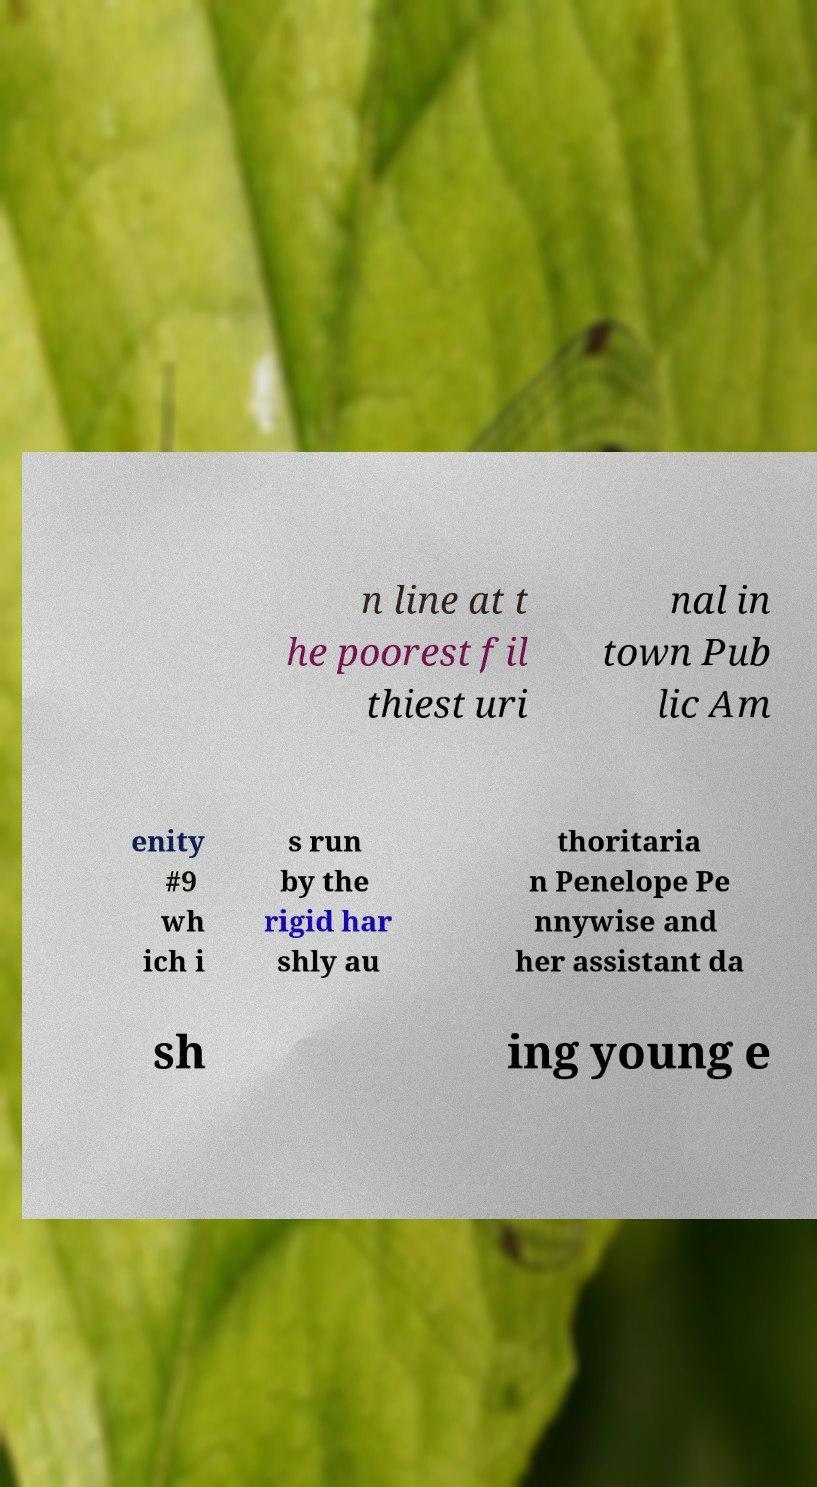Please identify and transcribe the text found in this image. n line at t he poorest fil thiest uri nal in town Pub lic Am enity #9 wh ich i s run by the rigid har shly au thoritaria n Penelope Pe nnywise and her assistant da sh ing young e 